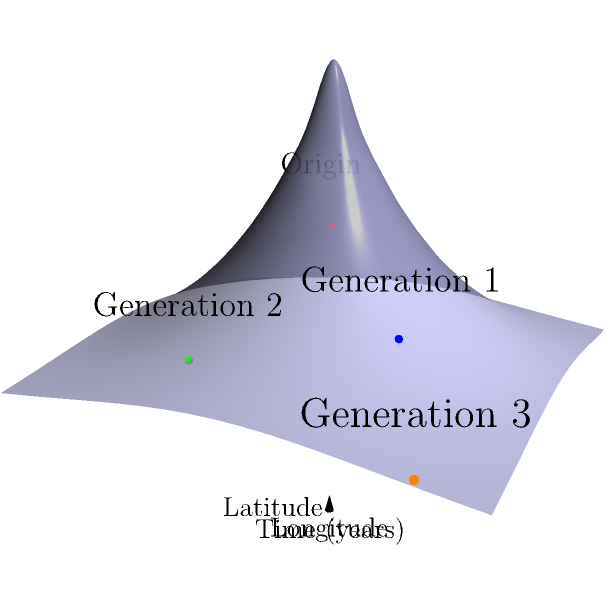In your historical fiction novel, you're visualizing your family's migration patterns over three generations using a 3D coordinate system. The x-axis represents time (in years), the y-axis represents longitude, and the z-axis represents latitude. If each generation moves approximately 50 years forward in time, and the most recent generation (Generation 3) is located at coordinates $(100, 75, 30)$, what would be the approximate coordinates of the origin point (your earliest known ancestor)? To solve this problem, we need to work backwards from Generation 3 to the origin point. Let's break it down step-by-step:

1. We know that Generation 3 is at coordinates $(100, 75, 30)$.
2. Each generation represents approximately 50 years.
3. We need to go back 3 generations, so we'll subtract 150 years from the x-coordinate (time axis).

4. For the y-coordinate (longitude) and z-coordinate (latitude), we don't have specific information about the rate of change. However, we can assume a linear change for simplicity.

5. To find the change per generation for y and z coordinates:
   y-coordinate change: $75 ÷ 3 = 25$ per generation
   z-coordinate change: $30 ÷ 3 = 10$ per generation

6. Now, let's calculate the origin point coordinates:
   x-coordinate: $100 - (3 * 50) = -50$
   y-coordinate: $75 - (3 * 25) = 0$
   z-coordinate: $30 - (3 * 10) = 0$

Therefore, the approximate coordinates of the origin point (earliest known ancestor) would be $(-50, 0, 0)$.
Answer: $(-50, 0, 0)$ 